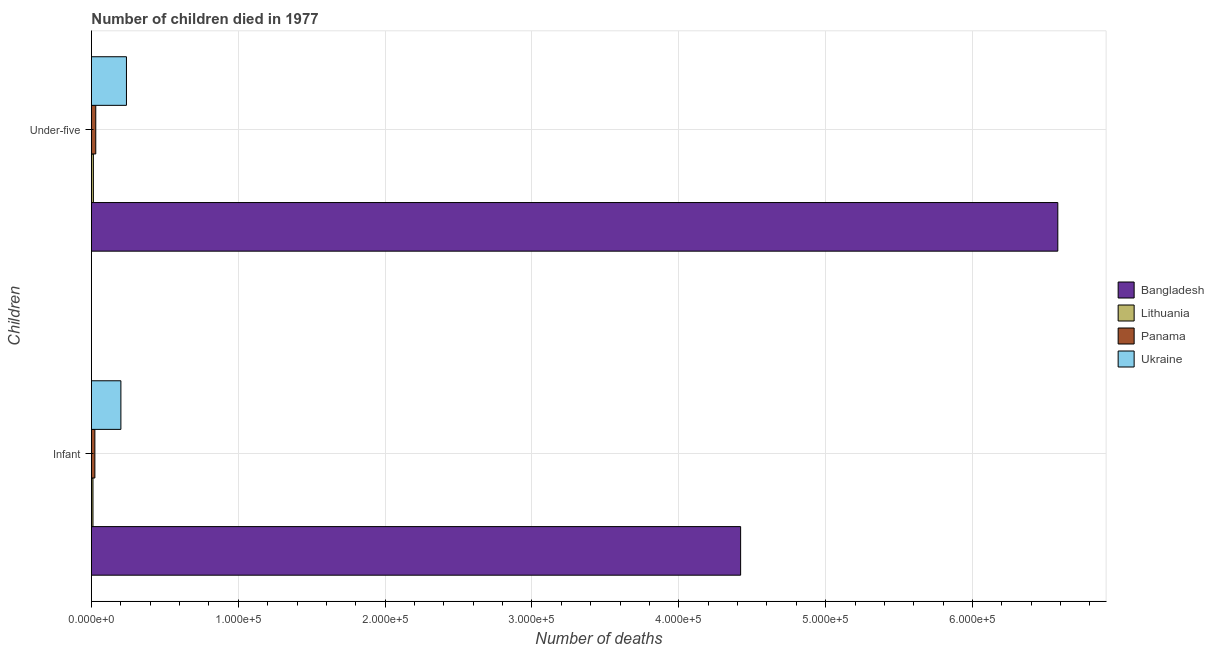How many different coloured bars are there?
Make the answer very short. 4. How many groups of bars are there?
Make the answer very short. 2. How many bars are there on the 1st tick from the top?
Offer a very short reply. 4. What is the label of the 2nd group of bars from the top?
Keep it short and to the point. Infant. What is the number of infant deaths in Ukraine?
Offer a terse response. 2.01e+04. Across all countries, what is the maximum number of infant deaths?
Provide a short and direct response. 4.42e+05. Across all countries, what is the minimum number of infant deaths?
Your response must be concise. 1057. In which country was the number of under-five deaths minimum?
Your response must be concise. Lithuania. What is the total number of infant deaths in the graph?
Offer a very short reply. 4.66e+05. What is the difference between the number of under-five deaths in Ukraine and that in Lithuania?
Give a very brief answer. 2.25e+04. What is the difference between the number of infant deaths in Bangladesh and the number of under-five deaths in Panama?
Ensure brevity in your answer.  4.39e+05. What is the average number of infant deaths per country?
Keep it short and to the point. 1.16e+05. What is the difference between the number of under-five deaths and number of infant deaths in Panama?
Your response must be concise. 609. In how many countries, is the number of infant deaths greater than 220000 ?
Your answer should be very brief. 1. What is the ratio of the number of infant deaths in Bangladesh to that in Lithuania?
Your answer should be very brief. 418.26. In how many countries, is the number of under-five deaths greater than the average number of under-five deaths taken over all countries?
Provide a short and direct response. 1. What does the 1st bar from the top in Infant represents?
Your answer should be very brief. Ukraine. What does the 4th bar from the bottom in Under-five represents?
Make the answer very short. Ukraine. Are all the bars in the graph horizontal?
Provide a succinct answer. Yes. What is the difference between two consecutive major ticks on the X-axis?
Offer a terse response. 1.00e+05. Does the graph contain any zero values?
Offer a terse response. No. How many legend labels are there?
Offer a very short reply. 4. What is the title of the graph?
Provide a short and direct response. Number of children died in 1977. Does "Bahrain" appear as one of the legend labels in the graph?
Ensure brevity in your answer.  No. What is the label or title of the X-axis?
Give a very brief answer. Number of deaths. What is the label or title of the Y-axis?
Your answer should be very brief. Children. What is the Number of deaths of Bangladesh in Infant?
Give a very brief answer. 4.42e+05. What is the Number of deaths in Lithuania in Infant?
Ensure brevity in your answer.  1057. What is the Number of deaths of Panama in Infant?
Provide a short and direct response. 2351. What is the Number of deaths in Ukraine in Infant?
Your response must be concise. 2.01e+04. What is the Number of deaths in Bangladesh in Under-five?
Make the answer very short. 6.58e+05. What is the Number of deaths of Lithuania in Under-five?
Your answer should be compact. 1331. What is the Number of deaths in Panama in Under-five?
Offer a very short reply. 2960. What is the Number of deaths in Ukraine in Under-five?
Provide a short and direct response. 2.39e+04. Across all Children, what is the maximum Number of deaths of Bangladesh?
Provide a short and direct response. 6.58e+05. Across all Children, what is the maximum Number of deaths of Lithuania?
Your answer should be very brief. 1331. Across all Children, what is the maximum Number of deaths in Panama?
Your response must be concise. 2960. Across all Children, what is the maximum Number of deaths in Ukraine?
Ensure brevity in your answer.  2.39e+04. Across all Children, what is the minimum Number of deaths in Bangladesh?
Your response must be concise. 4.42e+05. Across all Children, what is the minimum Number of deaths in Lithuania?
Your answer should be very brief. 1057. Across all Children, what is the minimum Number of deaths in Panama?
Offer a terse response. 2351. Across all Children, what is the minimum Number of deaths in Ukraine?
Your answer should be very brief. 2.01e+04. What is the total Number of deaths in Bangladesh in the graph?
Your answer should be compact. 1.10e+06. What is the total Number of deaths in Lithuania in the graph?
Offer a terse response. 2388. What is the total Number of deaths in Panama in the graph?
Make the answer very short. 5311. What is the total Number of deaths in Ukraine in the graph?
Your answer should be compact. 4.39e+04. What is the difference between the Number of deaths in Bangladesh in Infant and that in Under-five?
Your answer should be very brief. -2.16e+05. What is the difference between the Number of deaths in Lithuania in Infant and that in Under-five?
Offer a very short reply. -274. What is the difference between the Number of deaths of Panama in Infant and that in Under-five?
Ensure brevity in your answer.  -609. What is the difference between the Number of deaths in Ukraine in Infant and that in Under-five?
Make the answer very short. -3783. What is the difference between the Number of deaths in Bangladesh in Infant and the Number of deaths in Lithuania in Under-five?
Provide a succinct answer. 4.41e+05. What is the difference between the Number of deaths in Bangladesh in Infant and the Number of deaths in Panama in Under-five?
Keep it short and to the point. 4.39e+05. What is the difference between the Number of deaths in Bangladesh in Infant and the Number of deaths in Ukraine in Under-five?
Ensure brevity in your answer.  4.18e+05. What is the difference between the Number of deaths in Lithuania in Infant and the Number of deaths in Panama in Under-five?
Provide a short and direct response. -1903. What is the difference between the Number of deaths of Lithuania in Infant and the Number of deaths of Ukraine in Under-five?
Your answer should be very brief. -2.28e+04. What is the difference between the Number of deaths in Panama in Infant and the Number of deaths in Ukraine in Under-five?
Give a very brief answer. -2.15e+04. What is the average Number of deaths of Bangladesh per Children?
Ensure brevity in your answer.  5.50e+05. What is the average Number of deaths in Lithuania per Children?
Keep it short and to the point. 1194. What is the average Number of deaths of Panama per Children?
Offer a very short reply. 2655.5. What is the average Number of deaths of Ukraine per Children?
Your answer should be compact. 2.20e+04. What is the difference between the Number of deaths in Bangladesh and Number of deaths in Lithuania in Infant?
Your response must be concise. 4.41e+05. What is the difference between the Number of deaths in Bangladesh and Number of deaths in Panama in Infant?
Your answer should be very brief. 4.40e+05. What is the difference between the Number of deaths of Bangladesh and Number of deaths of Ukraine in Infant?
Make the answer very short. 4.22e+05. What is the difference between the Number of deaths of Lithuania and Number of deaths of Panama in Infant?
Provide a short and direct response. -1294. What is the difference between the Number of deaths of Lithuania and Number of deaths of Ukraine in Infant?
Your response must be concise. -1.90e+04. What is the difference between the Number of deaths of Panama and Number of deaths of Ukraine in Infant?
Make the answer very short. -1.77e+04. What is the difference between the Number of deaths in Bangladesh and Number of deaths in Lithuania in Under-five?
Provide a succinct answer. 6.57e+05. What is the difference between the Number of deaths of Bangladesh and Number of deaths of Panama in Under-five?
Ensure brevity in your answer.  6.55e+05. What is the difference between the Number of deaths of Bangladesh and Number of deaths of Ukraine in Under-five?
Give a very brief answer. 6.34e+05. What is the difference between the Number of deaths of Lithuania and Number of deaths of Panama in Under-five?
Your answer should be very brief. -1629. What is the difference between the Number of deaths in Lithuania and Number of deaths in Ukraine in Under-five?
Make the answer very short. -2.25e+04. What is the difference between the Number of deaths in Panama and Number of deaths in Ukraine in Under-five?
Your response must be concise. -2.09e+04. What is the ratio of the Number of deaths in Bangladesh in Infant to that in Under-five?
Ensure brevity in your answer.  0.67. What is the ratio of the Number of deaths of Lithuania in Infant to that in Under-five?
Offer a terse response. 0.79. What is the ratio of the Number of deaths of Panama in Infant to that in Under-five?
Give a very brief answer. 0.79. What is the ratio of the Number of deaths in Ukraine in Infant to that in Under-five?
Offer a very short reply. 0.84. What is the difference between the highest and the second highest Number of deaths of Bangladesh?
Provide a succinct answer. 2.16e+05. What is the difference between the highest and the second highest Number of deaths in Lithuania?
Ensure brevity in your answer.  274. What is the difference between the highest and the second highest Number of deaths of Panama?
Your answer should be very brief. 609. What is the difference between the highest and the second highest Number of deaths of Ukraine?
Offer a terse response. 3783. What is the difference between the highest and the lowest Number of deaths of Bangladesh?
Your answer should be compact. 2.16e+05. What is the difference between the highest and the lowest Number of deaths in Lithuania?
Provide a short and direct response. 274. What is the difference between the highest and the lowest Number of deaths in Panama?
Ensure brevity in your answer.  609. What is the difference between the highest and the lowest Number of deaths in Ukraine?
Your response must be concise. 3783. 